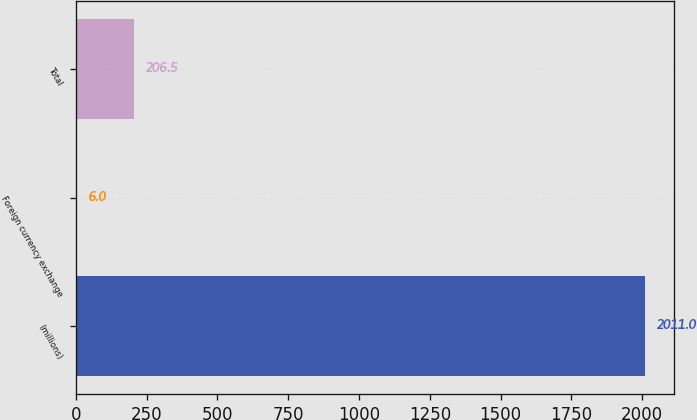<chart> <loc_0><loc_0><loc_500><loc_500><bar_chart><fcel>(millions)<fcel>Foreign currency exchange<fcel>Total<nl><fcel>2011<fcel>6<fcel>206.5<nl></chart> 